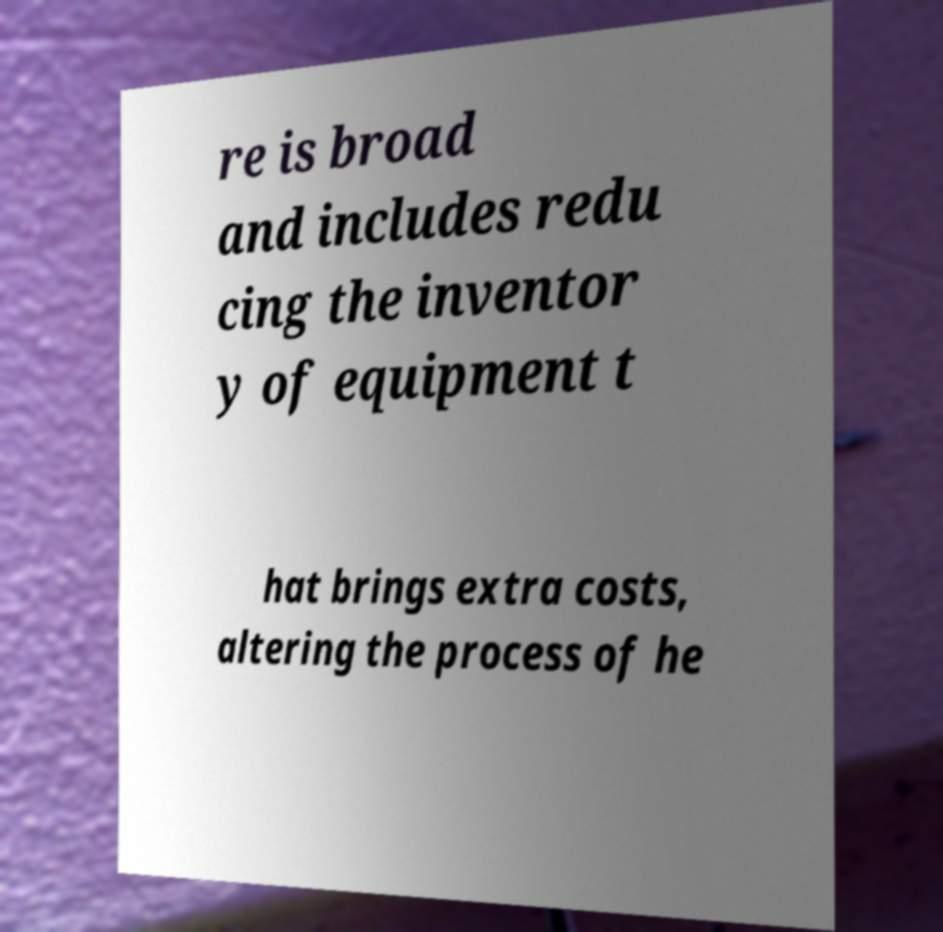For documentation purposes, I need the text within this image transcribed. Could you provide that? re is broad and includes redu cing the inventor y of equipment t hat brings extra costs, altering the process of he 